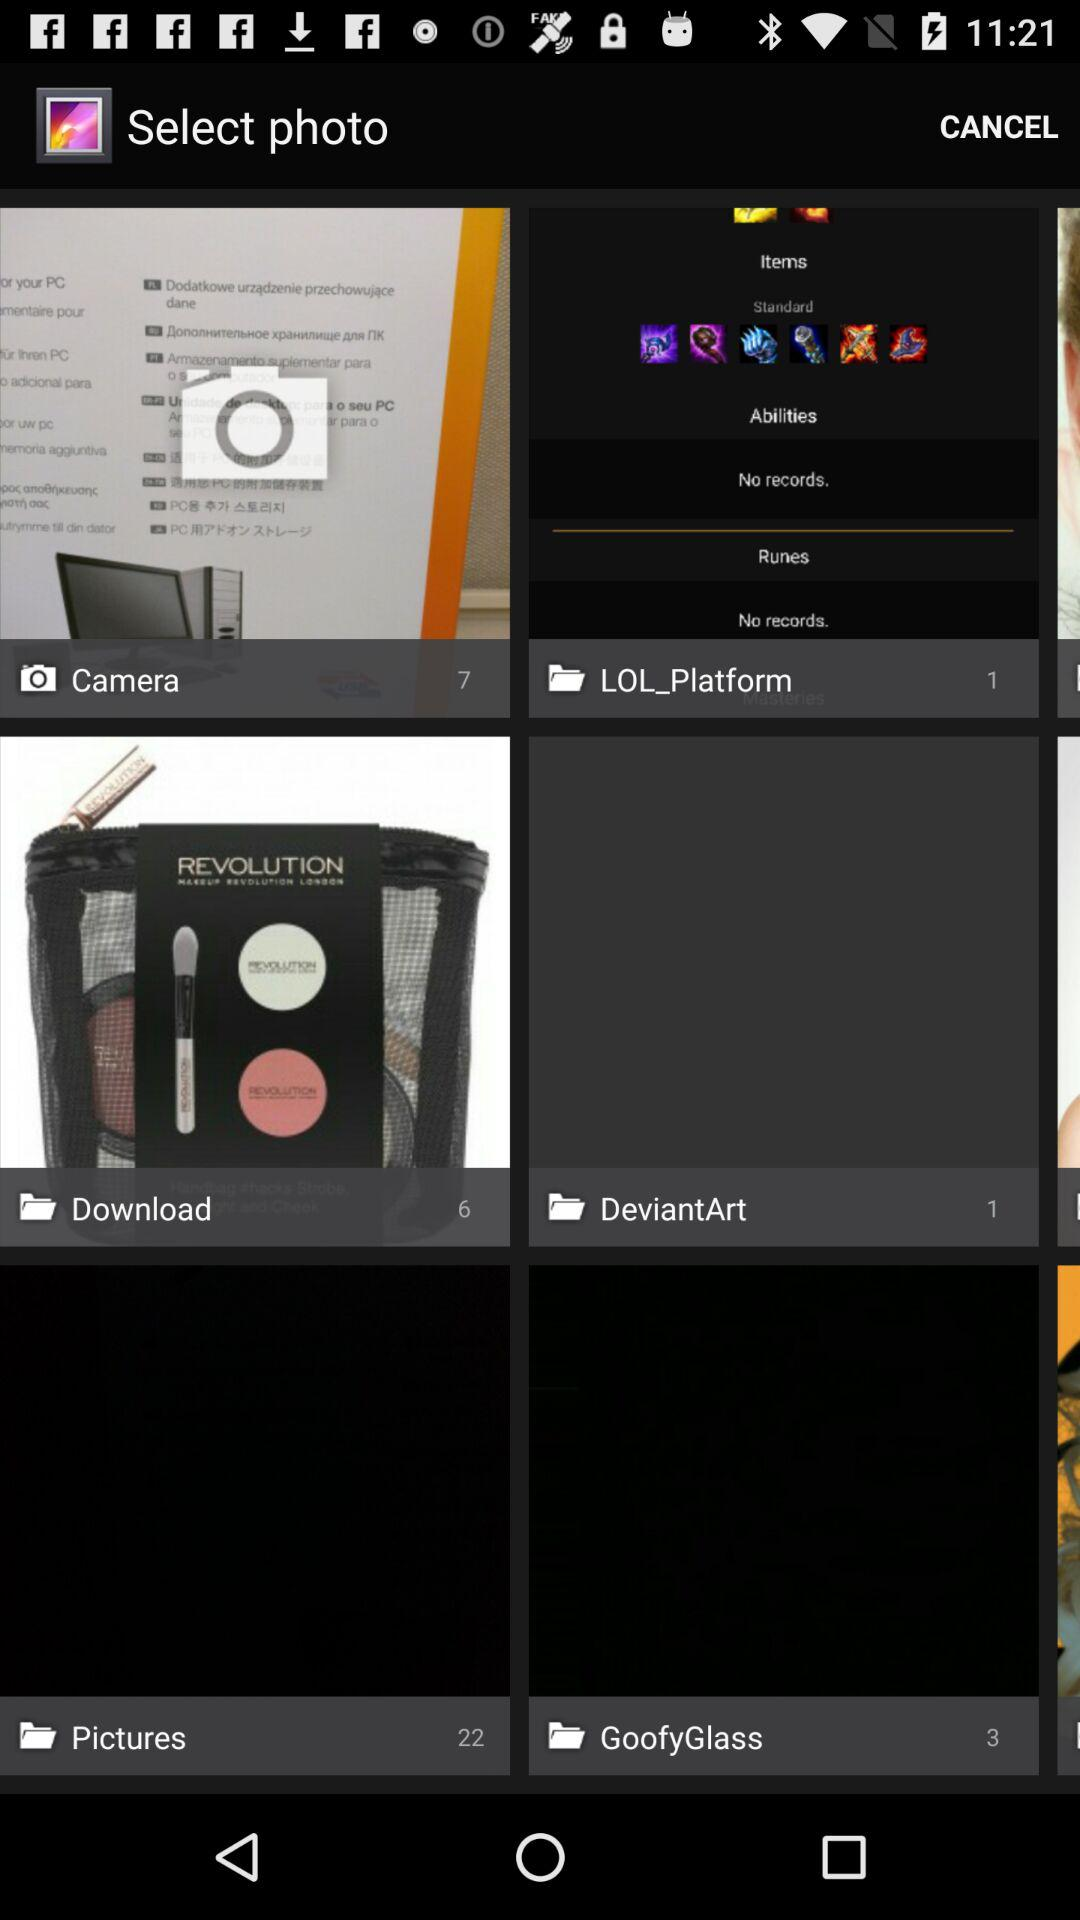How many images are in the "Camera" folder? There are 7 images in the "Camera" folder. 